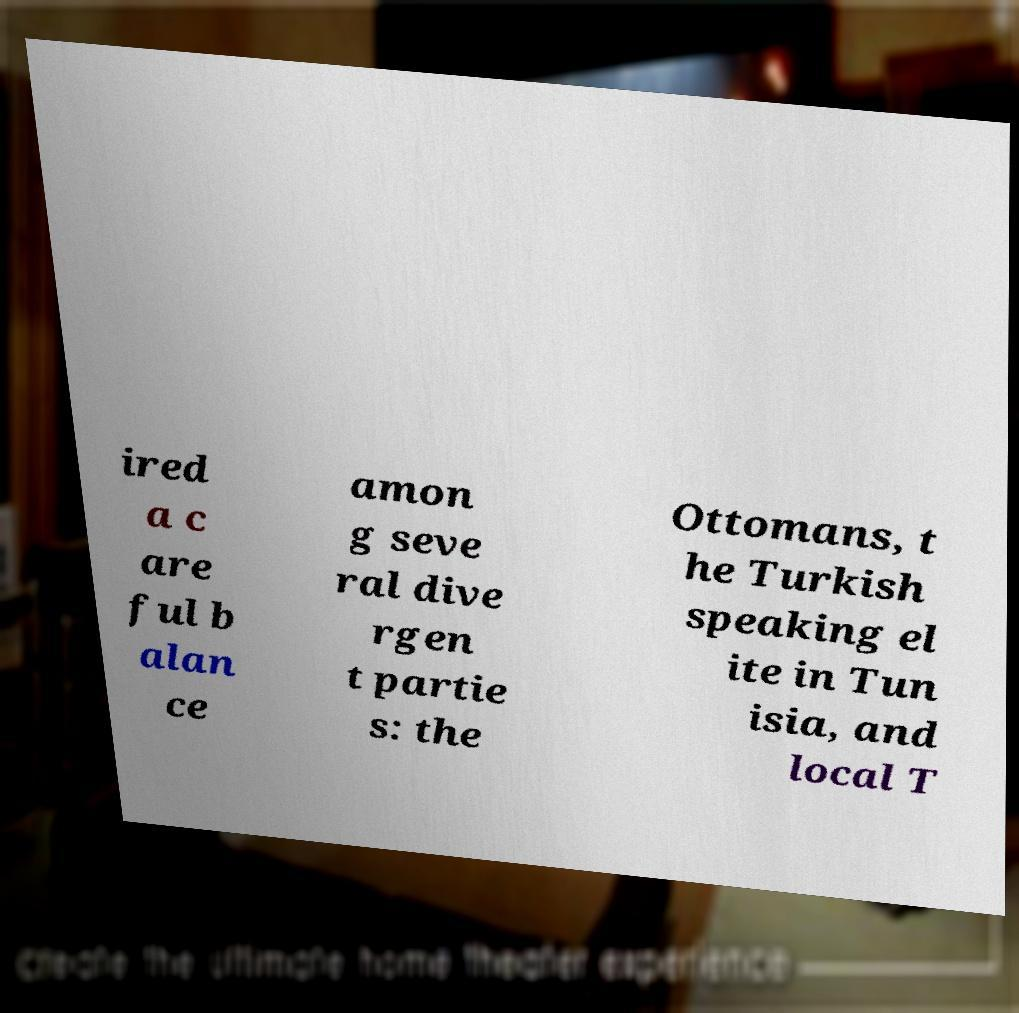For documentation purposes, I need the text within this image transcribed. Could you provide that? ired a c are ful b alan ce amon g seve ral dive rgen t partie s: the Ottomans, t he Turkish speaking el ite in Tun isia, and local T 